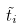Convert formula to latex. <formula><loc_0><loc_0><loc_500><loc_500>\tilde { t } _ { i }</formula> 